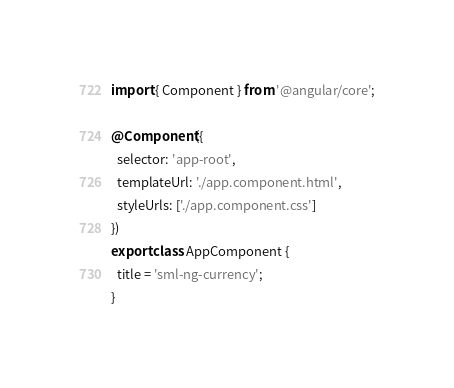<code> <loc_0><loc_0><loc_500><loc_500><_TypeScript_>import { Component } from '@angular/core';

@Component({
  selector: 'app-root',
  templateUrl: './app.component.html',
  styleUrls: ['./app.component.css']
})
export class AppComponent {
  title = 'sml-ng-currency';
}
</code> 